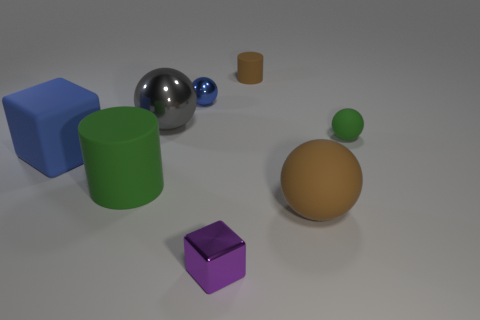Is the number of tiny green matte spheres that are on the right side of the tiny rubber ball greater than the number of metal blocks?
Ensure brevity in your answer.  No. Are there any gray things of the same shape as the small green rubber object?
Provide a succinct answer. Yes. Do the tiny brown cylinder and the large ball that is to the left of the purple object have the same material?
Give a very brief answer. No. What color is the small shiny ball?
Give a very brief answer. Blue. There is a tiny sphere that is right of the purple metal thing that is left of the small green ball; what number of rubber balls are in front of it?
Your response must be concise. 1. Are there any shiny balls in front of the big rubber block?
Offer a very short reply. No. How many tiny green things have the same material as the big block?
Offer a terse response. 1. What number of things are large purple things or large brown spheres?
Offer a very short reply. 1. Are any small gray cylinders visible?
Provide a succinct answer. No. The blue ball in front of the matte cylinder that is to the right of the tiny object that is in front of the small green thing is made of what material?
Give a very brief answer. Metal. 